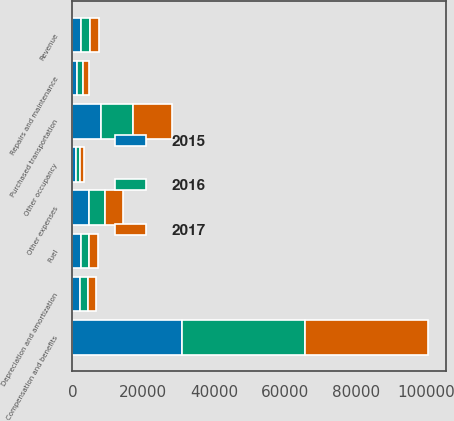Convert chart. <chart><loc_0><loc_0><loc_500><loc_500><stacked_bar_chart><ecel><fcel>Revenue<fcel>Compensation and benefits<fcel>Repairs and maintenance<fcel>Depreciation and amortization<fcel>Purchased transportation<fcel>Fuel<fcel>Other occupancy<fcel>Other expenses<nl><fcel>2017<fcel>2482<fcel>34588<fcel>1600<fcel>2282<fcel>10989<fcel>2690<fcel>1155<fcel>5039<nl><fcel>2016<fcel>2482<fcel>34770<fcel>1538<fcel>2224<fcel>9129<fcel>2118<fcel>1037<fcel>4623<nl><fcel>2015<fcel>2482<fcel>31028<fcel>1400<fcel>2084<fcel>8043<fcel>2482<fcel>1022<fcel>4636<nl></chart> 